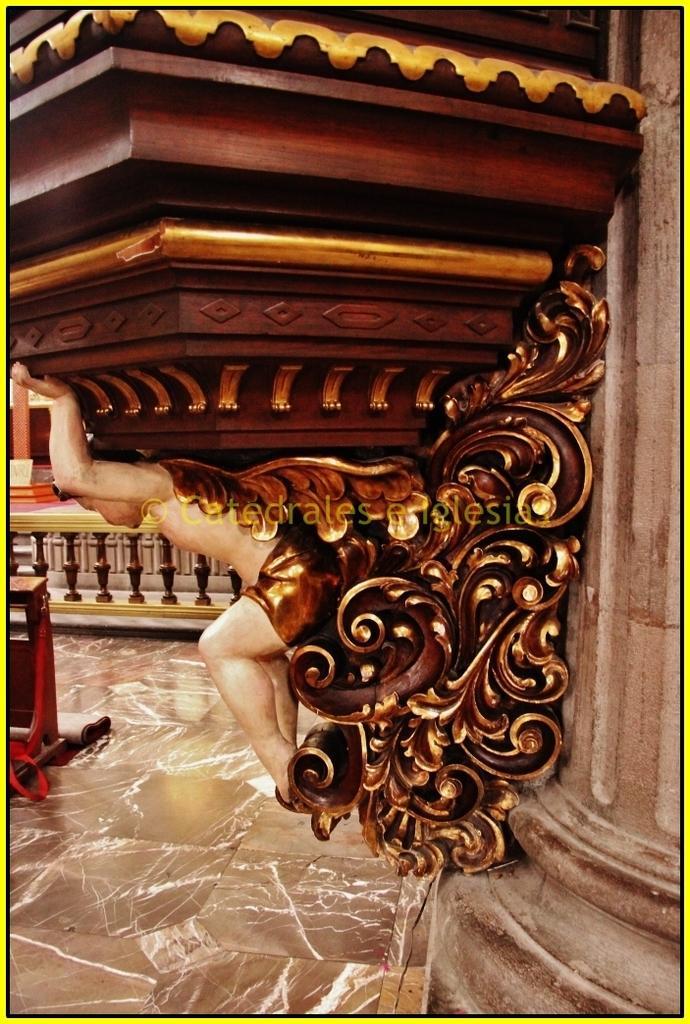Can you describe this image briefly? In this image there is a pillar truncated towards the right of the image, there is a sculptor attached to the pillar, there is an object truncated towards the left of the image, there is a pillar towards the left of the image. 